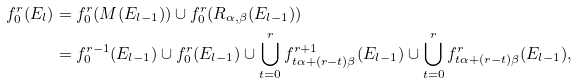Convert formula to latex. <formula><loc_0><loc_0><loc_500><loc_500>f _ { 0 } ^ { r } ( E _ { l } ) & = f _ { 0 } ^ { r } ( M ( E _ { l - 1 } ) ) \cup f _ { 0 } ^ { r } ( R _ { \alpha , \beta } ( E _ { l - 1 } ) ) \\ & = f _ { 0 } ^ { r - 1 } ( E _ { l - 1 } ) \cup f _ { 0 } ^ { r } ( E _ { l - 1 } ) \cup \bigcup _ { t = 0 } ^ { r } f ^ { r + 1 } _ { t \alpha + ( r - t ) \beta } ( E _ { l - 1 } ) \cup \bigcup _ { t = 0 } ^ { r } f ^ { r } _ { t \alpha + ( r - t ) \beta } ( E _ { l - 1 } ) ,</formula> 